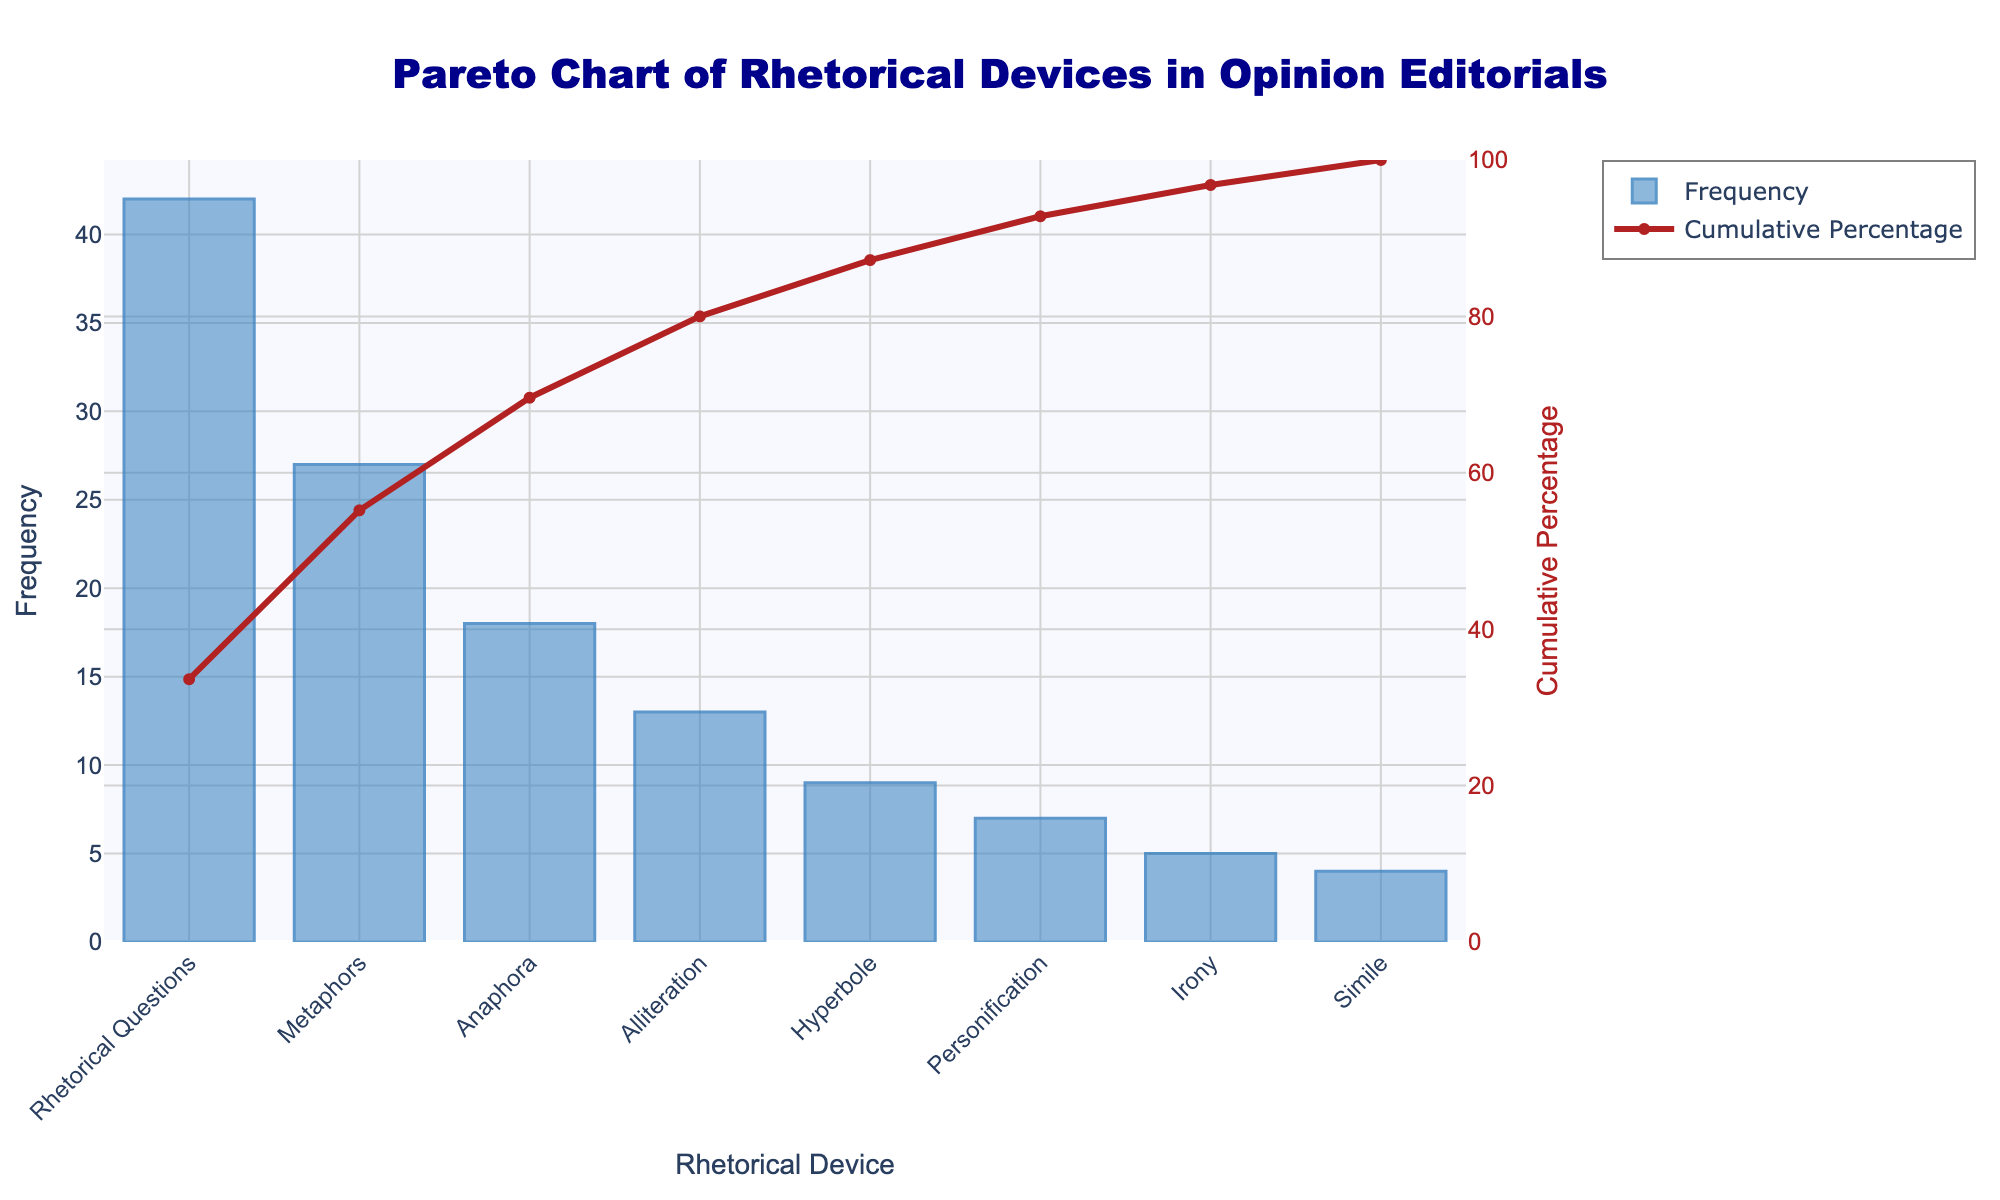What is the title of the figure? The title is usually located at the top of the figure, above the chart area. It is meant to describe what the chart is about.
Answer: Pareto Chart of Rhetorical Devices in Opinion Editorials What are the two primary types of data represented in the figure? A Pareto chart generally shows two types of data, with bars and a line indicating frequency and cumulative percentage, respectively.
Answer: Frequency and Cumulative Percentage Which rhetorical device has the highest frequency according to the chart? By observing the heights of the bars, the rhetorical device with the tallest bar is the one with the highest frequency.
Answer: Rhetorical Questions What is the cumulative percentage corresponding to Metaphors? Locate the bar labeled "Metaphors", then check the value of the cumulative percentage line at this point, which runs through the chart background.
Answer: Approximately 55% How many rhetorical devices have a frequency higher than 10? Count the number of bars that extend above the value of 10 on the y-axis labeled "Frequency".
Answer: 4 Which rhetorical device is the least frequently used according to the chart? Identify the shortest bar, as it represents the rhetorical device with the smallest frequency.
Answer: Simile Compare the frequencies of Anaphora and Hyperbole. Which one is more frequent? Find the bars for both Anaphora and Hyperbole, then compare their heights to determine which is taller.
Answer: Anaphora What is the approximate cumulative percentage for the top three rhetorical devices? Add up the frequencies of the top three devices and divide by the total frequency to find the cumulative percentage, which is represented by the cumulative percentage line in the chart.
Answer: 75% What cumulative percentage do the top 5 devices together represent? Sum the frequencies of the top five devices, then divide by the total frequency and multiply by 100 to calculate the cumulative percentage. This is visible in the chart as a point on the cumulative percentage line after the fifth device.
Answer: Approximately 90% What visual element distinguishes the cumulative percentage line from the frequency bars? Look for color, shape, or pattern differences between the bars and the line. The cumulative percentage line is usually a different color and style, such as a line graph compared to the bar graph for frequencies.
Answer: The cumulative percentage line is red and the frequency bars are blue 